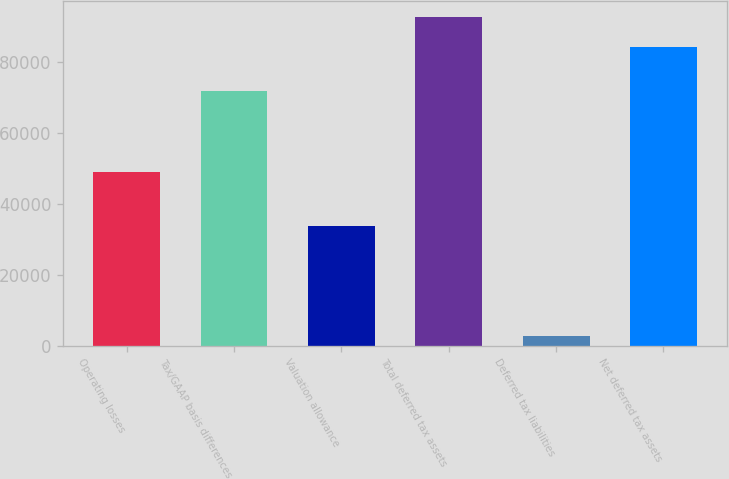Convert chart to OTSL. <chart><loc_0><loc_0><loc_500><loc_500><bar_chart><fcel>Operating losses<fcel>Tax/GAAP basis differences<fcel>Valuation allowance<fcel>Total deferred tax assets<fcel>Deferred tax liabilities<fcel>Net deferred tax assets<nl><fcel>48863<fcel>71747<fcel>33783<fcel>92588.1<fcel>2656<fcel>84171<nl></chart> 